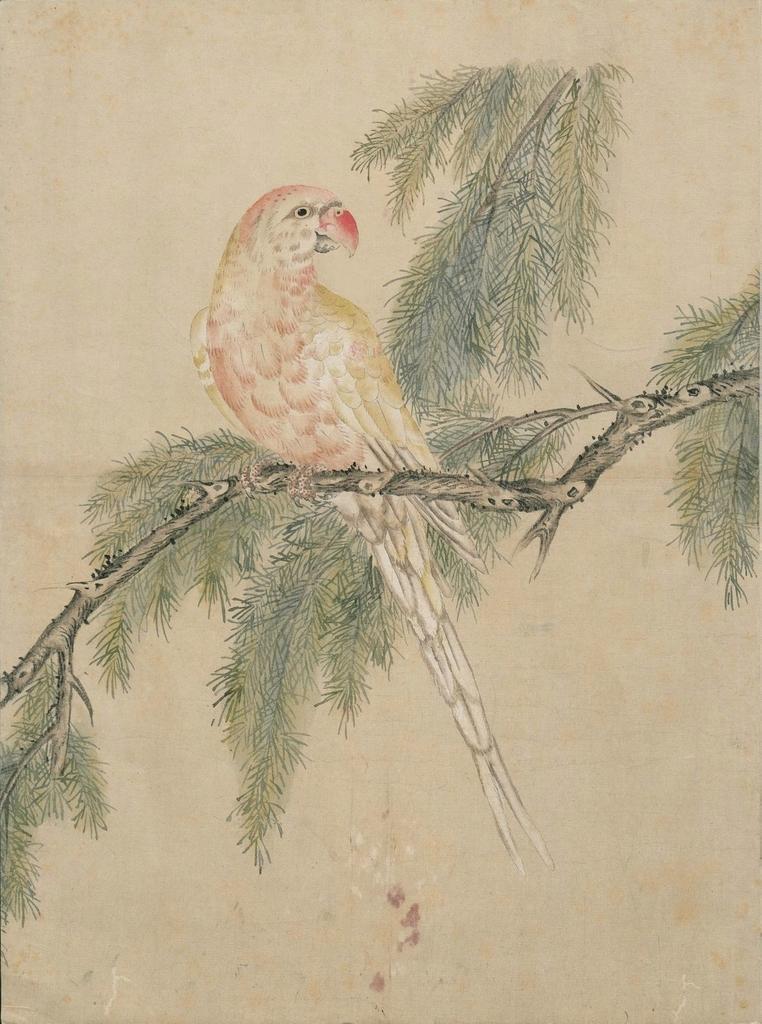Describe this image in one or two sentences. We can see painting of a bird on branch, leaves and stems. In the background it is cream color. 